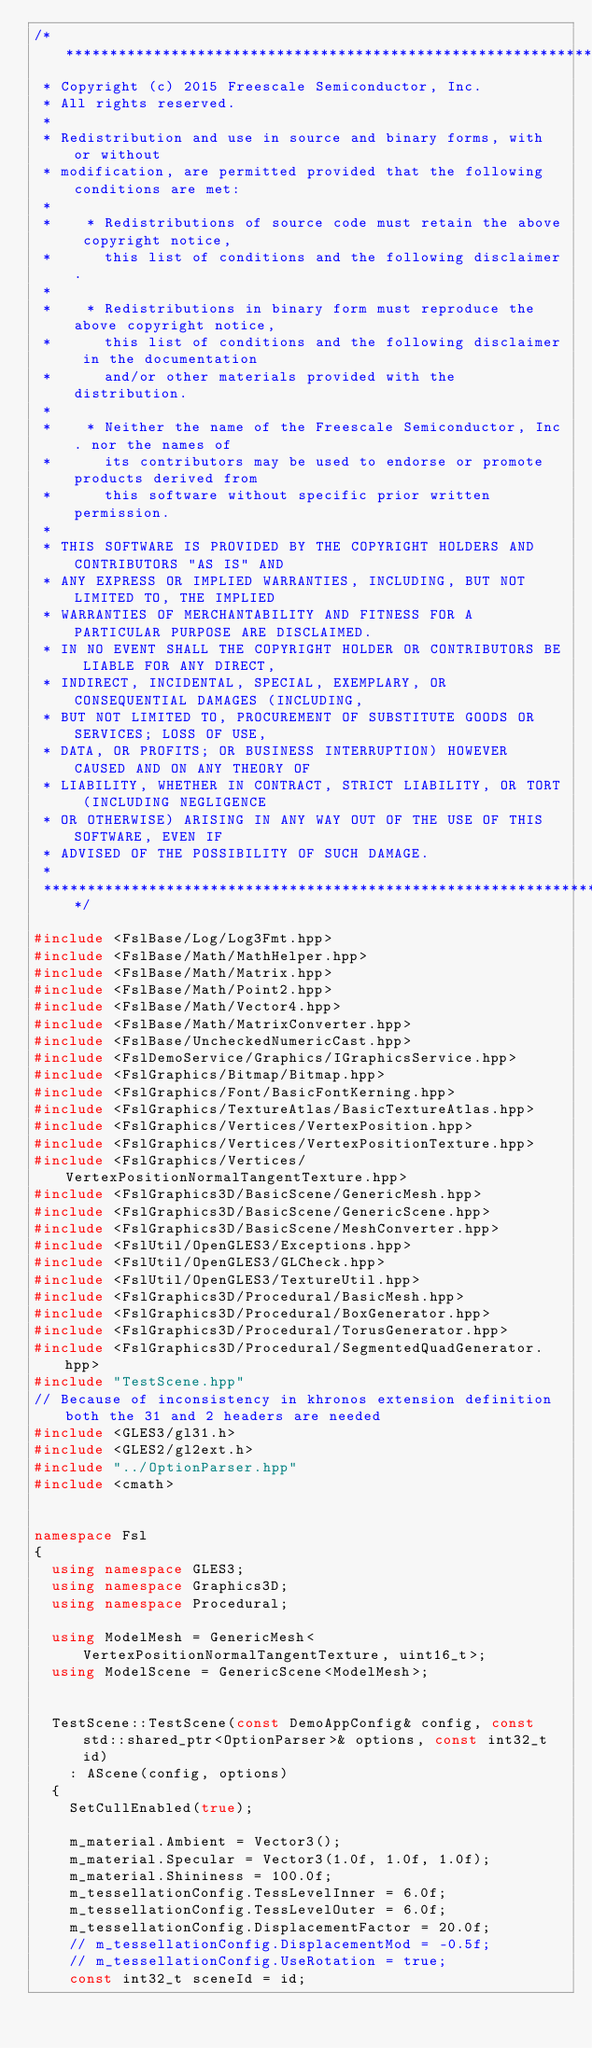<code> <loc_0><loc_0><loc_500><loc_500><_C++_>/****************************************************************************************************************************************************
 * Copyright (c) 2015 Freescale Semiconductor, Inc.
 * All rights reserved.
 *
 * Redistribution and use in source and binary forms, with or without
 * modification, are permitted provided that the following conditions are met:
 *
 *    * Redistributions of source code must retain the above copyright notice,
 *      this list of conditions and the following disclaimer.
 *
 *    * Redistributions in binary form must reproduce the above copyright notice,
 *      this list of conditions and the following disclaimer in the documentation
 *      and/or other materials provided with the distribution.
 *
 *    * Neither the name of the Freescale Semiconductor, Inc. nor the names of
 *      its contributors may be used to endorse or promote products derived from
 *      this software without specific prior written permission.
 *
 * THIS SOFTWARE IS PROVIDED BY THE COPYRIGHT HOLDERS AND CONTRIBUTORS "AS IS" AND
 * ANY EXPRESS OR IMPLIED WARRANTIES, INCLUDING, BUT NOT LIMITED TO, THE IMPLIED
 * WARRANTIES OF MERCHANTABILITY AND FITNESS FOR A PARTICULAR PURPOSE ARE DISCLAIMED.
 * IN NO EVENT SHALL THE COPYRIGHT HOLDER OR CONTRIBUTORS BE LIABLE FOR ANY DIRECT,
 * INDIRECT, INCIDENTAL, SPECIAL, EXEMPLARY, OR CONSEQUENTIAL DAMAGES (INCLUDING,
 * BUT NOT LIMITED TO, PROCUREMENT OF SUBSTITUTE GOODS OR SERVICES; LOSS OF USE,
 * DATA, OR PROFITS; OR BUSINESS INTERRUPTION) HOWEVER CAUSED AND ON ANY THEORY OF
 * LIABILITY, WHETHER IN CONTRACT, STRICT LIABILITY, OR TORT (INCLUDING NEGLIGENCE
 * OR OTHERWISE) ARISING IN ANY WAY OUT OF THE USE OF THIS SOFTWARE, EVEN IF
 * ADVISED OF THE POSSIBILITY OF SUCH DAMAGE.
 *
 ****************************************************************************************************************************************************/

#include <FslBase/Log/Log3Fmt.hpp>
#include <FslBase/Math/MathHelper.hpp>
#include <FslBase/Math/Matrix.hpp>
#include <FslBase/Math/Point2.hpp>
#include <FslBase/Math/Vector4.hpp>
#include <FslBase/Math/MatrixConverter.hpp>
#include <FslBase/UncheckedNumericCast.hpp>
#include <FslDemoService/Graphics/IGraphicsService.hpp>
#include <FslGraphics/Bitmap/Bitmap.hpp>
#include <FslGraphics/Font/BasicFontKerning.hpp>
#include <FslGraphics/TextureAtlas/BasicTextureAtlas.hpp>
#include <FslGraphics/Vertices/VertexPosition.hpp>
#include <FslGraphics/Vertices/VertexPositionTexture.hpp>
#include <FslGraphics/Vertices/VertexPositionNormalTangentTexture.hpp>
#include <FslGraphics3D/BasicScene/GenericMesh.hpp>
#include <FslGraphics3D/BasicScene/GenericScene.hpp>
#include <FslGraphics3D/BasicScene/MeshConverter.hpp>
#include <FslUtil/OpenGLES3/Exceptions.hpp>
#include <FslUtil/OpenGLES3/GLCheck.hpp>
#include <FslUtil/OpenGLES3/TextureUtil.hpp>
#include <FslGraphics3D/Procedural/BasicMesh.hpp>
#include <FslGraphics3D/Procedural/BoxGenerator.hpp>
#include <FslGraphics3D/Procedural/TorusGenerator.hpp>
#include <FslGraphics3D/Procedural/SegmentedQuadGenerator.hpp>
#include "TestScene.hpp"
// Because of inconsistency in khronos extension definition both the 31 and 2 headers are needed
#include <GLES3/gl31.h>
#include <GLES2/gl2ext.h>
#include "../OptionParser.hpp"
#include <cmath>


namespace Fsl
{
  using namespace GLES3;
  using namespace Graphics3D;
  using namespace Procedural;

  using ModelMesh = GenericMesh<VertexPositionNormalTangentTexture, uint16_t>;
  using ModelScene = GenericScene<ModelMesh>;


  TestScene::TestScene(const DemoAppConfig& config, const std::shared_ptr<OptionParser>& options, const int32_t id)
    : AScene(config, options)
  {
    SetCullEnabled(true);

    m_material.Ambient = Vector3();
    m_material.Specular = Vector3(1.0f, 1.0f, 1.0f);
    m_material.Shininess = 100.0f;
    m_tessellationConfig.TessLevelInner = 6.0f;
    m_tessellationConfig.TessLevelOuter = 6.0f;
    m_tessellationConfig.DisplacementFactor = 20.0f;
    // m_tessellationConfig.DisplacementMod = -0.5f;
    // m_tessellationConfig.UseRotation = true;
    const int32_t sceneId = id;</code> 